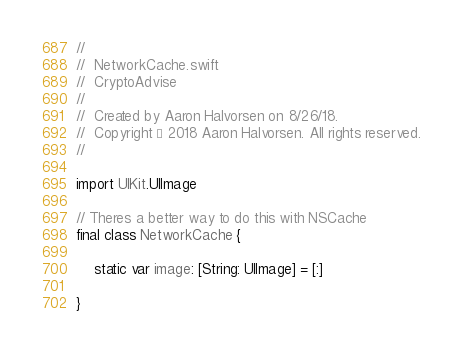Convert code to text. <code><loc_0><loc_0><loc_500><loc_500><_Swift_>//
//  NetworkCache.swift
//  CryptoAdvise
//
//  Created by Aaron Halvorsen on 8/26/18.
//  Copyright © 2018 Aaron Halvorsen. All rights reserved.
//

import UIKit.UIImage

// Theres a better way to do this with NSCache
final class NetworkCache {
    
    static var image: [String: UIImage] = [:]
    
}
</code> 